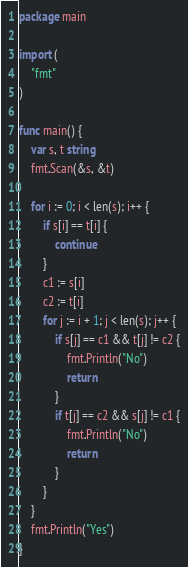Convert code to text. <code><loc_0><loc_0><loc_500><loc_500><_Go_>package main

import (
	"fmt"
)

func main() {
	var s, t string
	fmt.Scan(&s, &t)

	for i := 0; i < len(s); i++ {
		if s[i] == t[i] {
			continue
		}
		c1 := s[i]
		c2 := t[i]
		for j := i + 1; j < len(s); j++ {
			if s[j] == c1 && t[j] != c2 {
				fmt.Println("No")
				return
			}
			if t[j] == c2 && s[j] != c1 {
				fmt.Println("No")
				return
			}
		}
	}
	fmt.Println("Yes")
}
</code> 